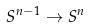Convert formula to latex. <formula><loc_0><loc_0><loc_500><loc_500>S ^ { n - 1 } \rightarrow S ^ { n }</formula> 